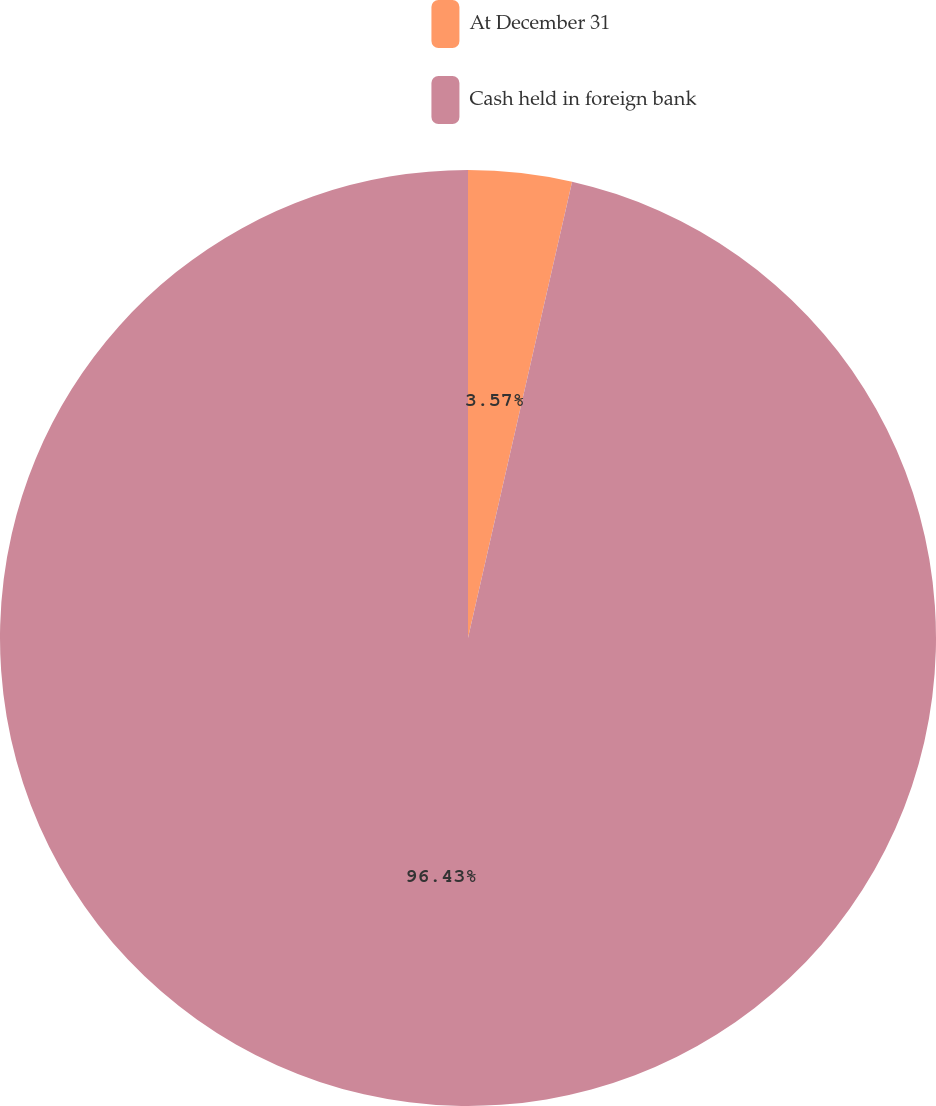<chart> <loc_0><loc_0><loc_500><loc_500><pie_chart><fcel>At December 31<fcel>Cash held in foreign bank<nl><fcel>3.57%<fcel>96.43%<nl></chart> 